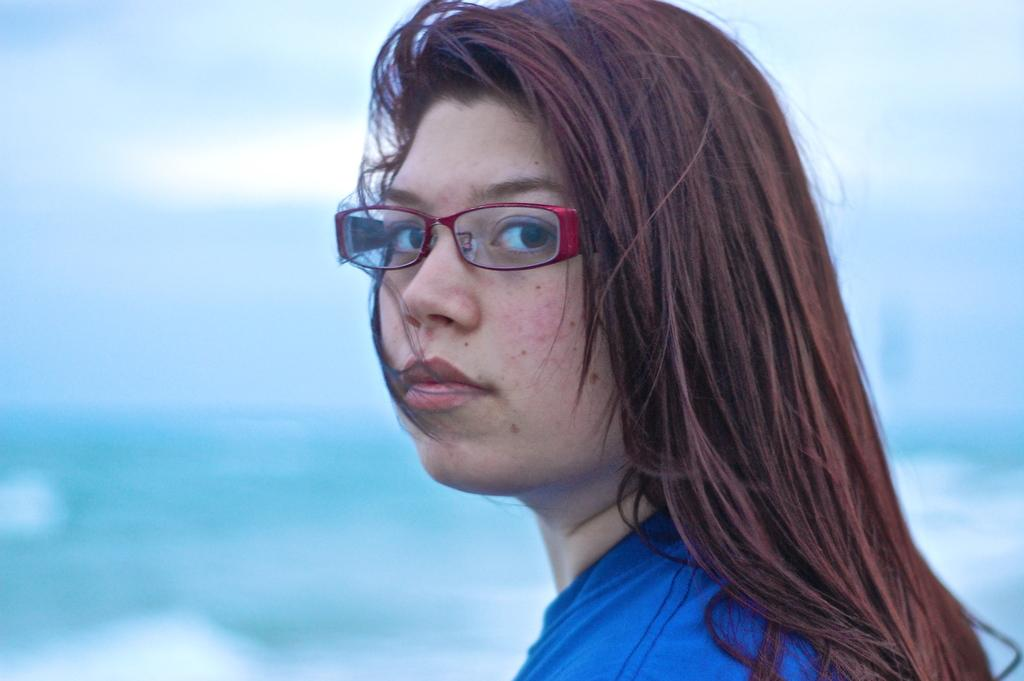What is the color of the background in the image? The background of the picture is blue. Who is present in the image? There is a woman in the image. What is the woman wearing? The woman is wearing a blue dress. What accessory is the woman wearing on her face? The woman is wearing spectacles. Can you see any worms crawling on the woman's dress in the image? No, there are no worms present in the image. 